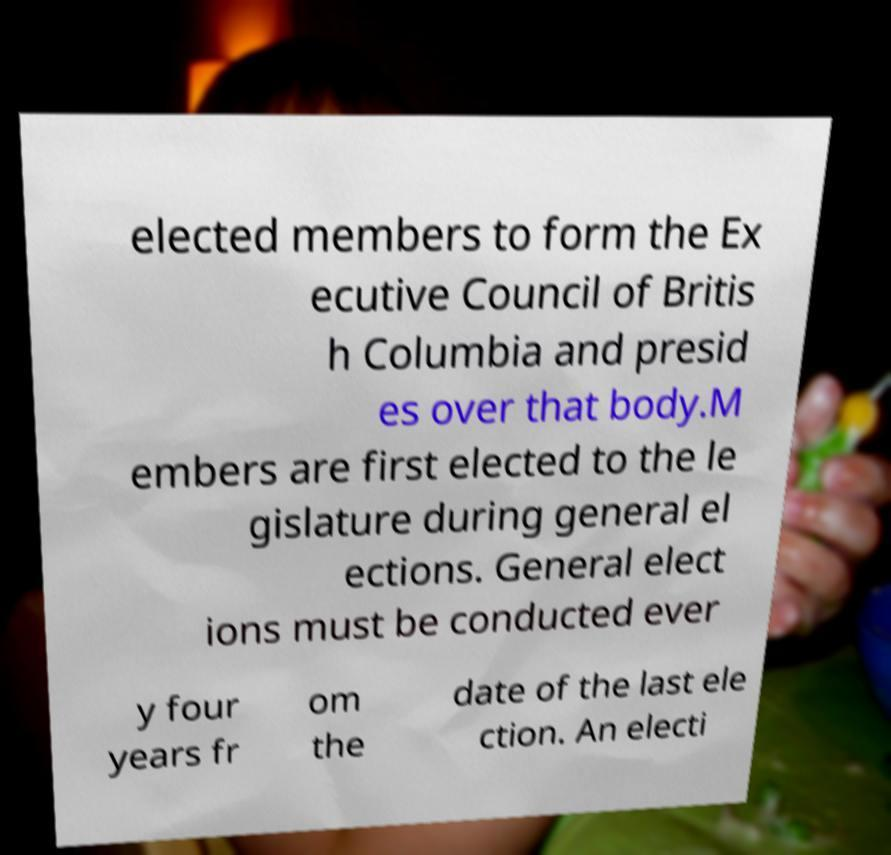Please read and relay the text visible in this image. What does it say? elected members to form the Ex ecutive Council of Britis h Columbia and presid es over that body.M embers are first elected to the le gislature during general el ections. General elect ions must be conducted ever y four years fr om the date of the last ele ction. An electi 